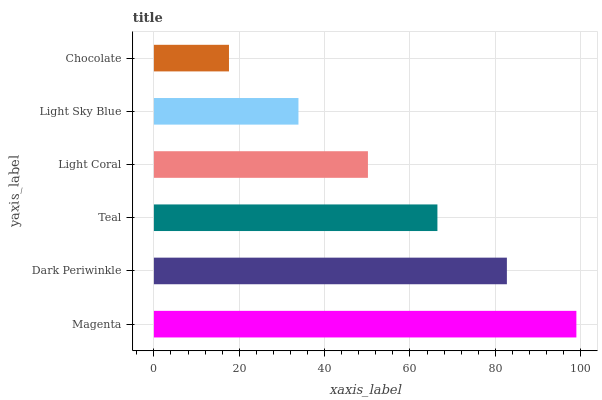Is Chocolate the minimum?
Answer yes or no. Yes. Is Magenta the maximum?
Answer yes or no. Yes. Is Dark Periwinkle the minimum?
Answer yes or no. No. Is Dark Periwinkle the maximum?
Answer yes or no. No. Is Magenta greater than Dark Periwinkle?
Answer yes or no. Yes. Is Dark Periwinkle less than Magenta?
Answer yes or no. Yes. Is Dark Periwinkle greater than Magenta?
Answer yes or no. No. Is Magenta less than Dark Periwinkle?
Answer yes or no. No. Is Teal the high median?
Answer yes or no. Yes. Is Light Coral the low median?
Answer yes or no. Yes. Is Dark Periwinkle the high median?
Answer yes or no. No. Is Dark Periwinkle the low median?
Answer yes or no. No. 